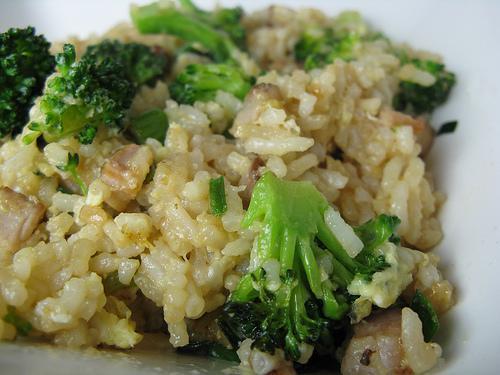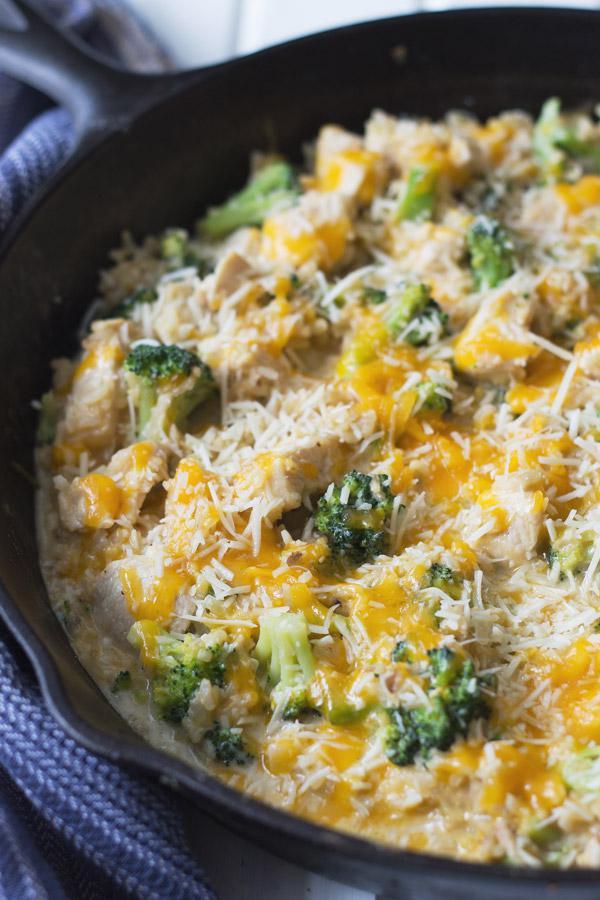The first image is the image on the left, the second image is the image on the right. Analyze the images presented: Is the assertion "Some of the food in one image is in a spoon." valid? Answer yes or no. No. 